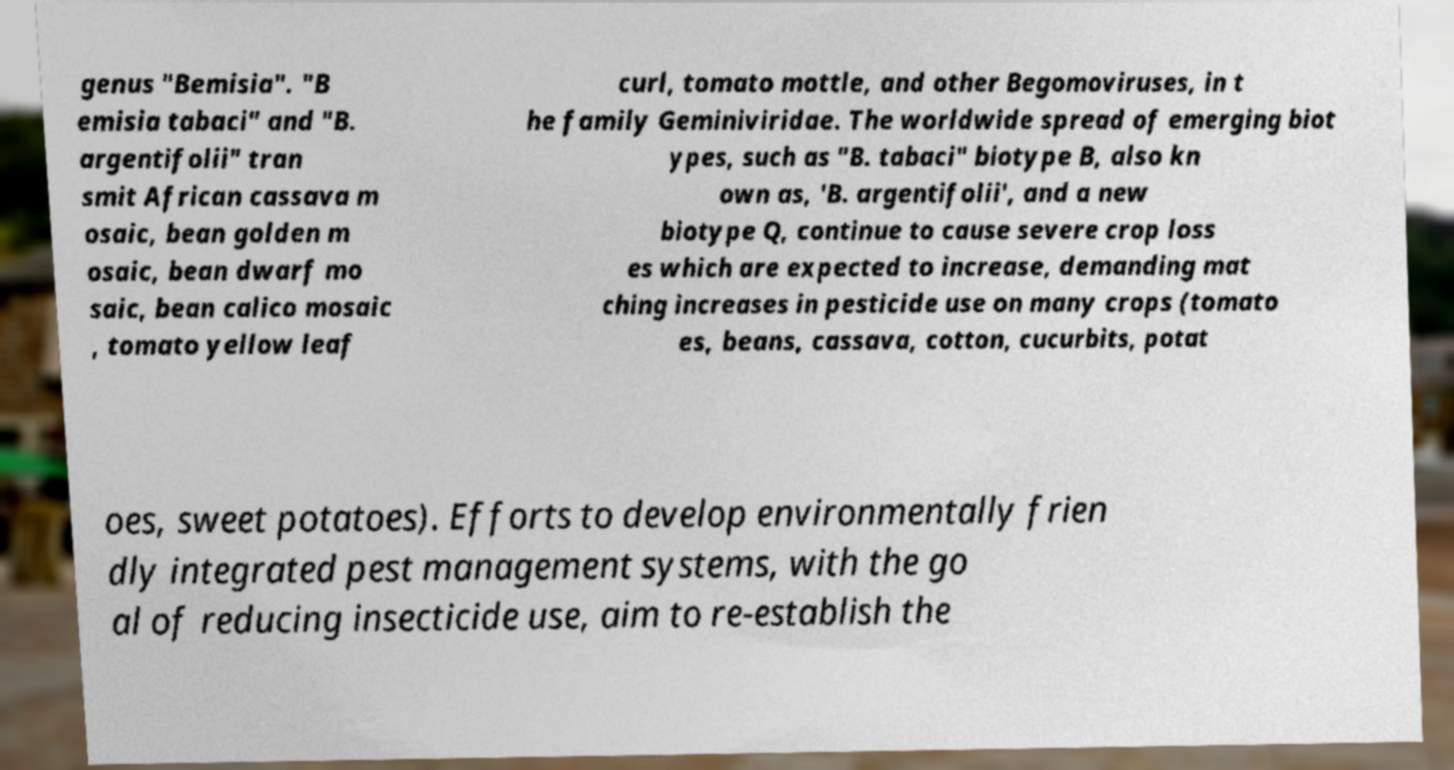I need the written content from this picture converted into text. Can you do that? genus "Bemisia". "B emisia tabaci" and "B. argentifolii" tran smit African cassava m osaic, bean golden m osaic, bean dwarf mo saic, bean calico mosaic , tomato yellow leaf curl, tomato mottle, and other Begomoviruses, in t he family Geminiviridae. The worldwide spread of emerging biot ypes, such as "B. tabaci" biotype B, also kn own as, 'B. argentifolii', and a new biotype Q, continue to cause severe crop loss es which are expected to increase, demanding mat ching increases in pesticide use on many crops (tomato es, beans, cassava, cotton, cucurbits, potat oes, sweet potatoes). Efforts to develop environmentally frien dly integrated pest management systems, with the go al of reducing insecticide use, aim to re-establish the 